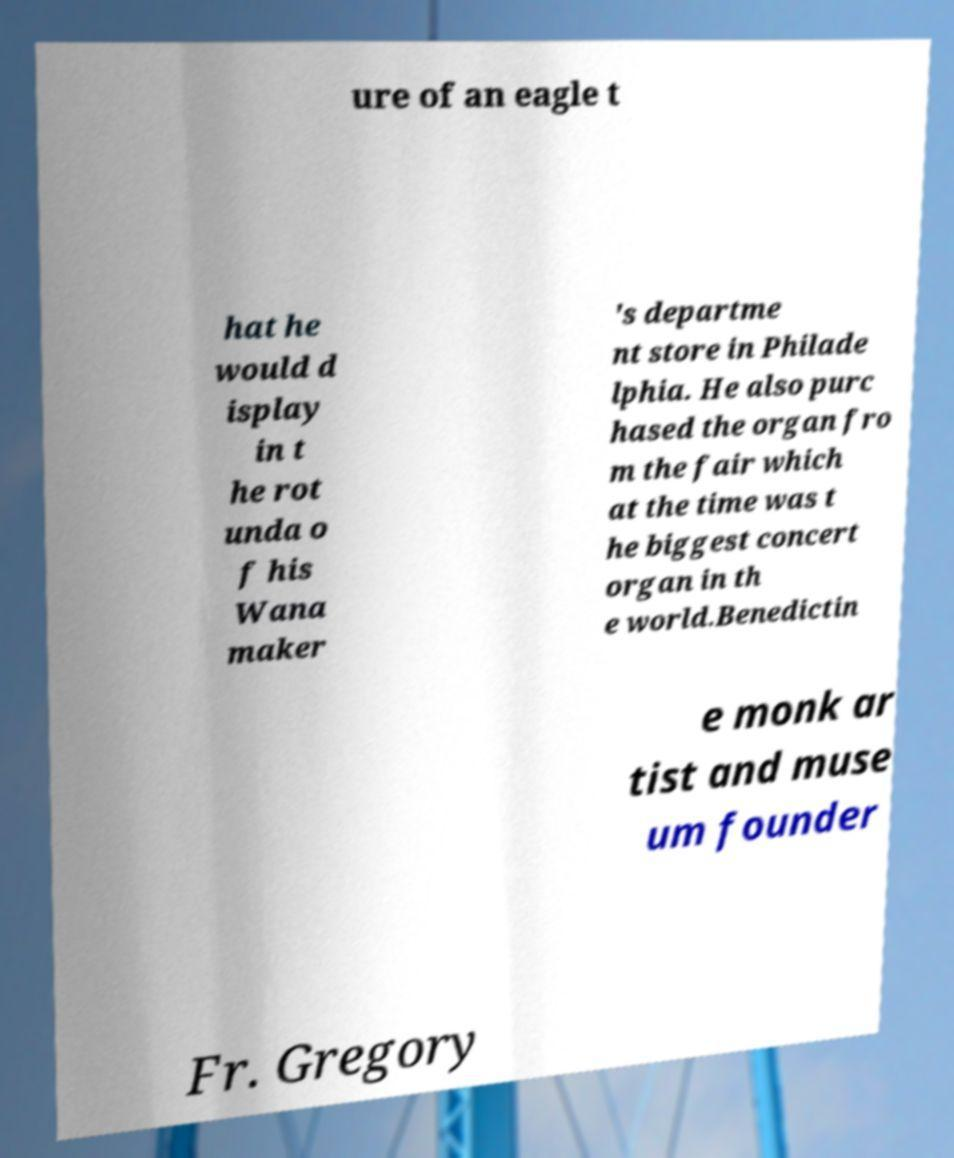What messages or text are displayed in this image? I need them in a readable, typed format. ure of an eagle t hat he would d isplay in t he rot unda o f his Wana maker 's departme nt store in Philade lphia. He also purc hased the organ fro m the fair which at the time was t he biggest concert organ in th e world.Benedictin e monk ar tist and muse um founder Fr. Gregory 